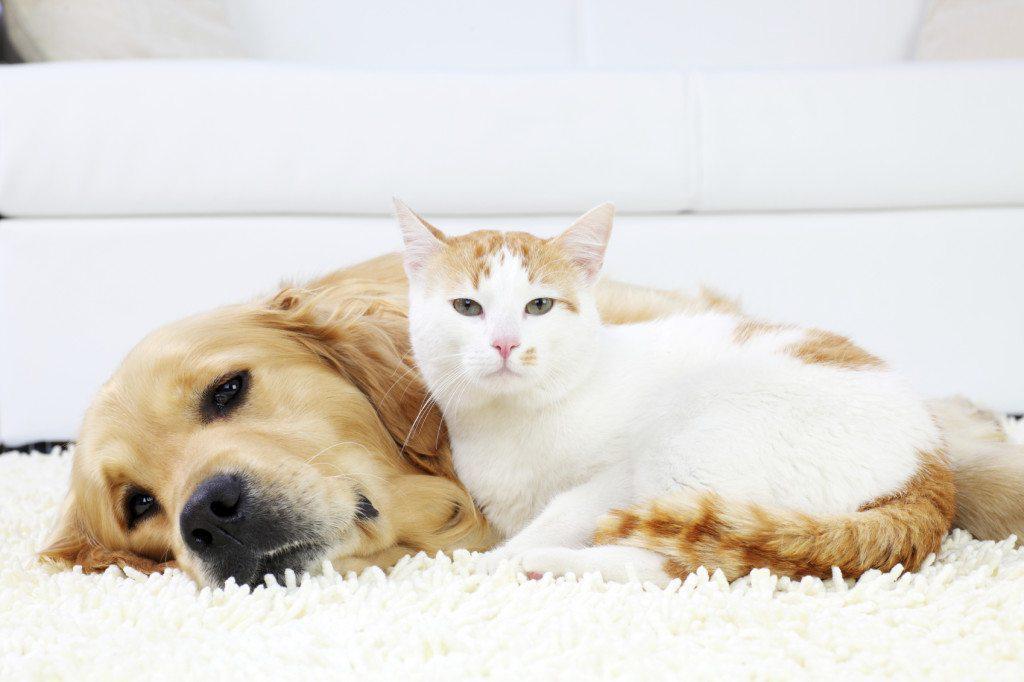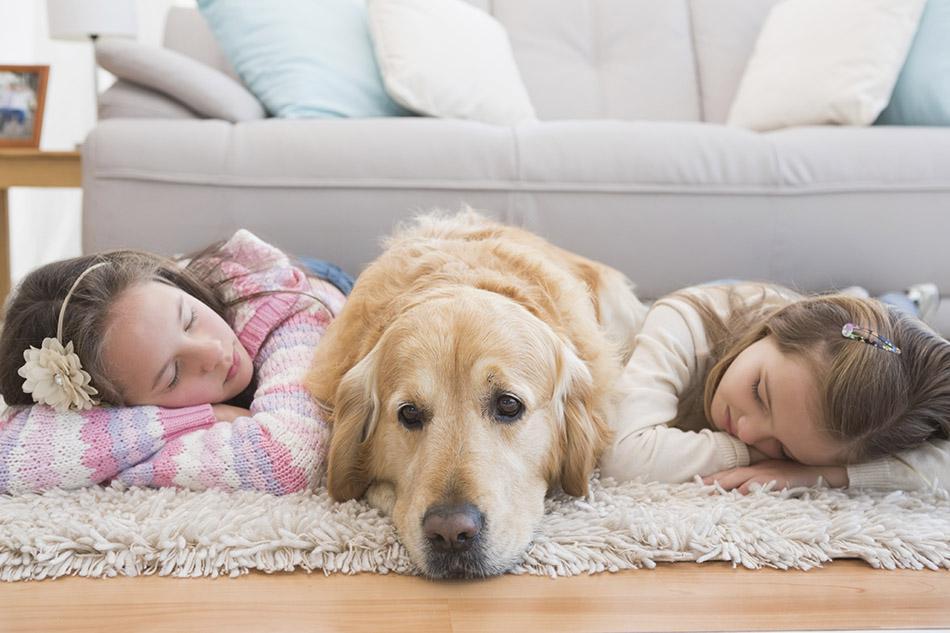The first image is the image on the left, the second image is the image on the right. Evaluate the accuracy of this statement regarding the images: "An image shows a dog and a cat together in a resting pose.". Is it true? Answer yes or no. Yes. The first image is the image on the left, the second image is the image on the right. Assess this claim about the two images: "A dog and a cat are lying down together.". Correct or not? Answer yes or no. Yes. 